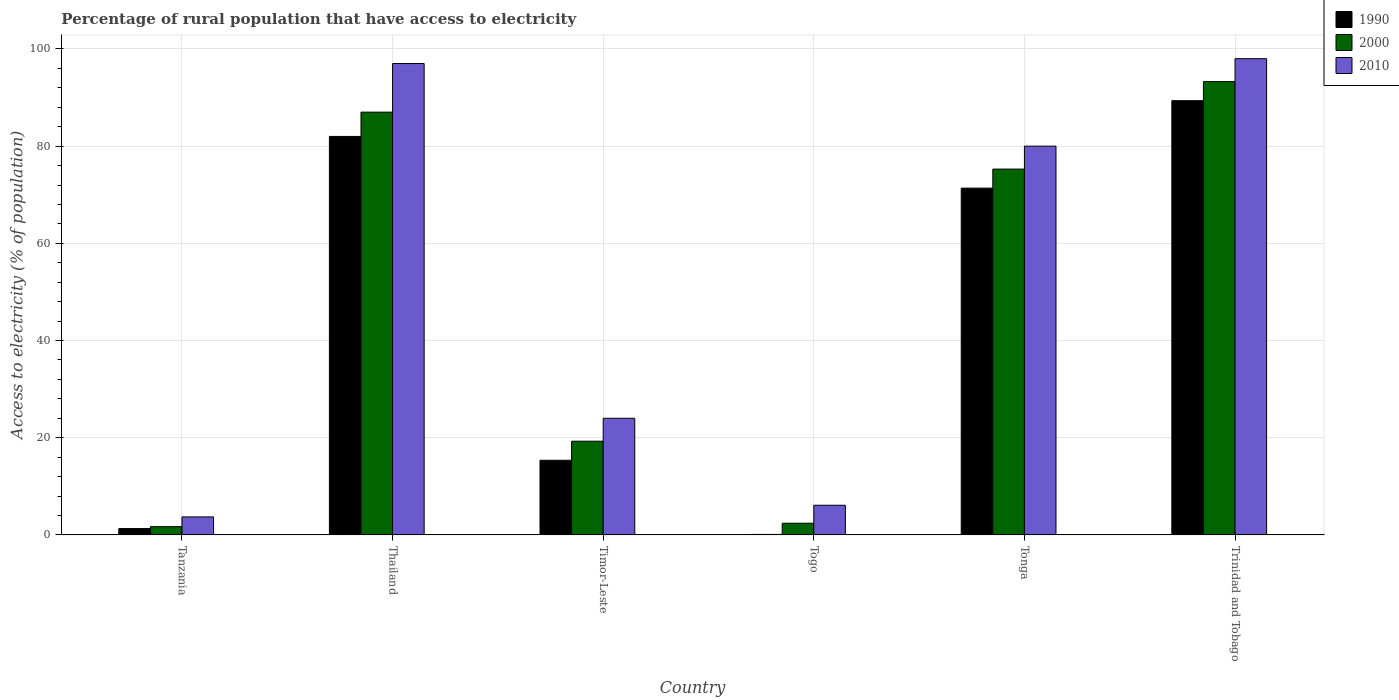Are the number of bars per tick equal to the number of legend labels?
Your answer should be very brief. Yes. Are the number of bars on each tick of the X-axis equal?
Offer a very short reply. Yes. How many bars are there on the 1st tick from the left?
Provide a succinct answer. 3. What is the label of the 1st group of bars from the left?
Your answer should be compact. Tanzania. What is the percentage of rural population that have access to electricity in 1990 in Tonga?
Make the answer very short. 71.36. Across all countries, what is the maximum percentage of rural population that have access to electricity in 2010?
Your response must be concise. 98. In which country was the percentage of rural population that have access to electricity in 2010 maximum?
Your answer should be very brief. Trinidad and Tobago. In which country was the percentage of rural population that have access to electricity in 1990 minimum?
Offer a terse response. Togo. What is the total percentage of rural population that have access to electricity in 1990 in the graph?
Make the answer very short. 259.48. What is the difference between the percentage of rural population that have access to electricity in 1990 in Tanzania and that in Thailand?
Your answer should be compact. -80.7. What is the difference between the percentage of rural population that have access to electricity in 2000 in Timor-Leste and the percentage of rural population that have access to electricity in 1990 in Tanzania?
Offer a very short reply. 17.98. What is the average percentage of rural population that have access to electricity in 2010 per country?
Your answer should be compact. 51.47. What is the difference between the percentage of rural population that have access to electricity of/in 2000 and percentage of rural population that have access to electricity of/in 1990 in Timor-Leste?
Your response must be concise. 3.92. What is the ratio of the percentage of rural population that have access to electricity in 1990 in Tanzania to that in Timor-Leste?
Provide a succinct answer. 0.08. Is the difference between the percentage of rural population that have access to electricity in 2000 in Thailand and Tonga greater than the difference between the percentage of rural population that have access to electricity in 1990 in Thailand and Tonga?
Give a very brief answer. Yes. What is the difference between the highest and the second highest percentage of rural population that have access to electricity in 2000?
Offer a terse response. -18. What is the difference between the highest and the lowest percentage of rural population that have access to electricity in 2000?
Make the answer very short. 91.58. In how many countries, is the percentage of rural population that have access to electricity in 2010 greater than the average percentage of rural population that have access to electricity in 2010 taken over all countries?
Your answer should be very brief. 3. Is the sum of the percentage of rural population that have access to electricity in 2000 in Tanzania and Tonga greater than the maximum percentage of rural population that have access to electricity in 2010 across all countries?
Give a very brief answer. No. What does the 3rd bar from the right in Thailand represents?
Provide a succinct answer. 1990. Is it the case that in every country, the sum of the percentage of rural population that have access to electricity in 2010 and percentage of rural population that have access to electricity in 1990 is greater than the percentage of rural population that have access to electricity in 2000?
Make the answer very short. Yes. How many bars are there?
Provide a succinct answer. 18. Are all the bars in the graph horizontal?
Provide a short and direct response. No. What is the difference between two consecutive major ticks on the Y-axis?
Offer a terse response. 20. How many legend labels are there?
Give a very brief answer. 3. How are the legend labels stacked?
Ensure brevity in your answer.  Vertical. What is the title of the graph?
Your response must be concise. Percentage of rural population that have access to electricity. Does "2008" appear as one of the legend labels in the graph?
Give a very brief answer. No. What is the label or title of the X-axis?
Ensure brevity in your answer.  Country. What is the label or title of the Y-axis?
Keep it short and to the point. Access to electricity (% of population). What is the Access to electricity (% of population) in 1990 in Tanzania?
Offer a terse response. 1.3. What is the Access to electricity (% of population) of 2010 in Thailand?
Your response must be concise. 97. What is the Access to electricity (% of population) in 1990 in Timor-Leste?
Ensure brevity in your answer.  15.36. What is the Access to electricity (% of population) of 2000 in Timor-Leste?
Keep it short and to the point. 19.28. What is the Access to electricity (% of population) in 2010 in Timor-Leste?
Ensure brevity in your answer.  24. What is the Access to electricity (% of population) in 1990 in Togo?
Your answer should be compact. 0.1. What is the Access to electricity (% of population) of 1990 in Tonga?
Offer a terse response. 71.36. What is the Access to electricity (% of population) of 2000 in Tonga?
Provide a succinct answer. 75.28. What is the Access to electricity (% of population) in 2010 in Tonga?
Ensure brevity in your answer.  80. What is the Access to electricity (% of population) in 1990 in Trinidad and Tobago?
Give a very brief answer. 89.36. What is the Access to electricity (% of population) in 2000 in Trinidad and Tobago?
Give a very brief answer. 93.28. Across all countries, what is the maximum Access to electricity (% of population) of 1990?
Provide a succinct answer. 89.36. Across all countries, what is the maximum Access to electricity (% of population) in 2000?
Make the answer very short. 93.28. Across all countries, what is the maximum Access to electricity (% of population) of 2010?
Offer a terse response. 98. Across all countries, what is the minimum Access to electricity (% of population) of 1990?
Ensure brevity in your answer.  0.1. What is the total Access to electricity (% of population) of 1990 in the graph?
Offer a terse response. 259.48. What is the total Access to electricity (% of population) in 2000 in the graph?
Ensure brevity in your answer.  278.94. What is the total Access to electricity (% of population) in 2010 in the graph?
Give a very brief answer. 308.8. What is the difference between the Access to electricity (% of population) in 1990 in Tanzania and that in Thailand?
Your answer should be very brief. -80.7. What is the difference between the Access to electricity (% of population) of 2000 in Tanzania and that in Thailand?
Keep it short and to the point. -85.3. What is the difference between the Access to electricity (% of population) of 2010 in Tanzania and that in Thailand?
Keep it short and to the point. -93.3. What is the difference between the Access to electricity (% of population) in 1990 in Tanzania and that in Timor-Leste?
Provide a short and direct response. -14.06. What is the difference between the Access to electricity (% of population) of 2000 in Tanzania and that in Timor-Leste?
Offer a very short reply. -17.58. What is the difference between the Access to electricity (% of population) in 2010 in Tanzania and that in Timor-Leste?
Make the answer very short. -20.3. What is the difference between the Access to electricity (% of population) of 2000 in Tanzania and that in Togo?
Your answer should be very brief. -0.7. What is the difference between the Access to electricity (% of population) of 1990 in Tanzania and that in Tonga?
Your response must be concise. -70.06. What is the difference between the Access to electricity (% of population) of 2000 in Tanzania and that in Tonga?
Your answer should be compact. -73.58. What is the difference between the Access to electricity (% of population) of 2010 in Tanzania and that in Tonga?
Offer a terse response. -76.3. What is the difference between the Access to electricity (% of population) in 1990 in Tanzania and that in Trinidad and Tobago?
Keep it short and to the point. -88.06. What is the difference between the Access to electricity (% of population) in 2000 in Tanzania and that in Trinidad and Tobago?
Keep it short and to the point. -91.58. What is the difference between the Access to electricity (% of population) in 2010 in Tanzania and that in Trinidad and Tobago?
Ensure brevity in your answer.  -94.3. What is the difference between the Access to electricity (% of population) in 1990 in Thailand and that in Timor-Leste?
Keep it short and to the point. 66.64. What is the difference between the Access to electricity (% of population) in 2000 in Thailand and that in Timor-Leste?
Offer a terse response. 67.72. What is the difference between the Access to electricity (% of population) of 1990 in Thailand and that in Togo?
Make the answer very short. 81.9. What is the difference between the Access to electricity (% of population) in 2000 in Thailand and that in Togo?
Provide a short and direct response. 84.6. What is the difference between the Access to electricity (% of population) of 2010 in Thailand and that in Togo?
Give a very brief answer. 90.9. What is the difference between the Access to electricity (% of population) in 1990 in Thailand and that in Tonga?
Make the answer very short. 10.64. What is the difference between the Access to electricity (% of population) of 2000 in Thailand and that in Tonga?
Make the answer very short. 11.72. What is the difference between the Access to electricity (% of population) of 2010 in Thailand and that in Tonga?
Provide a short and direct response. 17. What is the difference between the Access to electricity (% of population) of 1990 in Thailand and that in Trinidad and Tobago?
Ensure brevity in your answer.  -7.36. What is the difference between the Access to electricity (% of population) in 2000 in Thailand and that in Trinidad and Tobago?
Provide a succinct answer. -6.28. What is the difference between the Access to electricity (% of population) in 1990 in Timor-Leste and that in Togo?
Give a very brief answer. 15.26. What is the difference between the Access to electricity (% of population) in 2000 in Timor-Leste and that in Togo?
Offer a very short reply. 16.88. What is the difference between the Access to electricity (% of population) of 1990 in Timor-Leste and that in Tonga?
Give a very brief answer. -56. What is the difference between the Access to electricity (% of population) in 2000 in Timor-Leste and that in Tonga?
Offer a terse response. -56. What is the difference between the Access to electricity (% of population) in 2010 in Timor-Leste and that in Tonga?
Give a very brief answer. -56. What is the difference between the Access to electricity (% of population) of 1990 in Timor-Leste and that in Trinidad and Tobago?
Offer a very short reply. -74. What is the difference between the Access to electricity (% of population) in 2000 in Timor-Leste and that in Trinidad and Tobago?
Provide a short and direct response. -74. What is the difference between the Access to electricity (% of population) of 2010 in Timor-Leste and that in Trinidad and Tobago?
Your response must be concise. -74. What is the difference between the Access to electricity (% of population) of 1990 in Togo and that in Tonga?
Offer a terse response. -71.26. What is the difference between the Access to electricity (% of population) of 2000 in Togo and that in Tonga?
Keep it short and to the point. -72.88. What is the difference between the Access to electricity (% of population) of 2010 in Togo and that in Tonga?
Provide a succinct answer. -73.9. What is the difference between the Access to electricity (% of population) of 1990 in Togo and that in Trinidad and Tobago?
Ensure brevity in your answer.  -89.26. What is the difference between the Access to electricity (% of population) in 2000 in Togo and that in Trinidad and Tobago?
Keep it short and to the point. -90.88. What is the difference between the Access to electricity (% of population) in 2010 in Togo and that in Trinidad and Tobago?
Your answer should be compact. -91.9. What is the difference between the Access to electricity (% of population) of 2000 in Tonga and that in Trinidad and Tobago?
Your answer should be compact. -18. What is the difference between the Access to electricity (% of population) in 1990 in Tanzania and the Access to electricity (% of population) in 2000 in Thailand?
Make the answer very short. -85.7. What is the difference between the Access to electricity (% of population) in 1990 in Tanzania and the Access to electricity (% of population) in 2010 in Thailand?
Ensure brevity in your answer.  -95.7. What is the difference between the Access to electricity (% of population) of 2000 in Tanzania and the Access to electricity (% of population) of 2010 in Thailand?
Give a very brief answer. -95.3. What is the difference between the Access to electricity (% of population) in 1990 in Tanzania and the Access to electricity (% of population) in 2000 in Timor-Leste?
Your response must be concise. -17.98. What is the difference between the Access to electricity (% of population) of 1990 in Tanzania and the Access to electricity (% of population) of 2010 in Timor-Leste?
Keep it short and to the point. -22.7. What is the difference between the Access to electricity (% of population) of 2000 in Tanzania and the Access to electricity (% of population) of 2010 in Timor-Leste?
Your answer should be very brief. -22.3. What is the difference between the Access to electricity (% of population) of 1990 in Tanzania and the Access to electricity (% of population) of 2010 in Togo?
Make the answer very short. -4.8. What is the difference between the Access to electricity (% of population) in 2000 in Tanzania and the Access to electricity (% of population) in 2010 in Togo?
Offer a terse response. -4.4. What is the difference between the Access to electricity (% of population) in 1990 in Tanzania and the Access to electricity (% of population) in 2000 in Tonga?
Offer a very short reply. -73.98. What is the difference between the Access to electricity (% of population) of 1990 in Tanzania and the Access to electricity (% of population) of 2010 in Tonga?
Give a very brief answer. -78.7. What is the difference between the Access to electricity (% of population) in 2000 in Tanzania and the Access to electricity (% of population) in 2010 in Tonga?
Offer a terse response. -78.3. What is the difference between the Access to electricity (% of population) in 1990 in Tanzania and the Access to electricity (% of population) in 2000 in Trinidad and Tobago?
Make the answer very short. -91.98. What is the difference between the Access to electricity (% of population) of 1990 in Tanzania and the Access to electricity (% of population) of 2010 in Trinidad and Tobago?
Ensure brevity in your answer.  -96.7. What is the difference between the Access to electricity (% of population) in 2000 in Tanzania and the Access to electricity (% of population) in 2010 in Trinidad and Tobago?
Give a very brief answer. -96.3. What is the difference between the Access to electricity (% of population) of 1990 in Thailand and the Access to electricity (% of population) of 2000 in Timor-Leste?
Provide a short and direct response. 62.72. What is the difference between the Access to electricity (% of population) of 1990 in Thailand and the Access to electricity (% of population) of 2010 in Timor-Leste?
Your response must be concise. 58. What is the difference between the Access to electricity (% of population) of 1990 in Thailand and the Access to electricity (% of population) of 2000 in Togo?
Make the answer very short. 79.6. What is the difference between the Access to electricity (% of population) in 1990 in Thailand and the Access to electricity (% of population) in 2010 in Togo?
Your response must be concise. 75.9. What is the difference between the Access to electricity (% of population) in 2000 in Thailand and the Access to electricity (% of population) in 2010 in Togo?
Give a very brief answer. 80.9. What is the difference between the Access to electricity (% of population) of 1990 in Thailand and the Access to electricity (% of population) of 2000 in Tonga?
Offer a very short reply. 6.72. What is the difference between the Access to electricity (% of population) in 1990 in Thailand and the Access to electricity (% of population) in 2010 in Tonga?
Ensure brevity in your answer.  2. What is the difference between the Access to electricity (% of population) of 1990 in Thailand and the Access to electricity (% of population) of 2000 in Trinidad and Tobago?
Offer a terse response. -11.28. What is the difference between the Access to electricity (% of population) in 1990 in Thailand and the Access to electricity (% of population) in 2010 in Trinidad and Tobago?
Give a very brief answer. -16. What is the difference between the Access to electricity (% of population) of 1990 in Timor-Leste and the Access to electricity (% of population) of 2000 in Togo?
Your answer should be compact. 12.96. What is the difference between the Access to electricity (% of population) of 1990 in Timor-Leste and the Access to electricity (% of population) of 2010 in Togo?
Offer a terse response. 9.26. What is the difference between the Access to electricity (% of population) of 2000 in Timor-Leste and the Access to electricity (% of population) of 2010 in Togo?
Offer a terse response. 13.18. What is the difference between the Access to electricity (% of population) of 1990 in Timor-Leste and the Access to electricity (% of population) of 2000 in Tonga?
Ensure brevity in your answer.  -59.92. What is the difference between the Access to electricity (% of population) in 1990 in Timor-Leste and the Access to electricity (% of population) in 2010 in Tonga?
Offer a terse response. -64.64. What is the difference between the Access to electricity (% of population) of 2000 in Timor-Leste and the Access to electricity (% of population) of 2010 in Tonga?
Make the answer very short. -60.72. What is the difference between the Access to electricity (% of population) of 1990 in Timor-Leste and the Access to electricity (% of population) of 2000 in Trinidad and Tobago?
Provide a short and direct response. -77.92. What is the difference between the Access to electricity (% of population) of 1990 in Timor-Leste and the Access to electricity (% of population) of 2010 in Trinidad and Tobago?
Keep it short and to the point. -82.64. What is the difference between the Access to electricity (% of population) in 2000 in Timor-Leste and the Access to electricity (% of population) in 2010 in Trinidad and Tobago?
Your answer should be very brief. -78.72. What is the difference between the Access to electricity (% of population) in 1990 in Togo and the Access to electricity (% of population) in 2000 in Tonga?
Make the answer very short. -75.18. What is the difference between the Access to electricity (% of population) of 1990 in Togo and the Access to electricity (% of population) of 2010 in Tonga?
Your answer should be very brief. -79.9. What is the difference between the Access to electricity (% of population) of 2000 in Togo and the Access to electricity (% of population) of 2010 in Tonga?
Keep it short and to the point. -77.6. What is the difference between the Access to electricity (% of population) in 1990 in Togo and the Access to electricity (% of population) in 2000 in Trinidad and Tobago?
Your response must be concise. -93.18. What is the difference between the Access to electricity (% of population) in 1990 in Togo and the Access to electricity (% of population) in 2010 in Trinidad and Tobago?
Offer a very short reply. -97.9. What is the difference between the Access to electricity (% of population) of 2000 in Togo and the Access to electricity (% of population) of 2010 in Trinidad and Tobago?
Your answer should be very brief. -95.6. What is the difference between the Access to electricity (% of population) of 1990 in Tonga and the Access to electricity (% of population) of 2000 in Trinidad and Tobago?
Offer a very short reply. -21.92. What is the difference between the Access to electricity (% of population) of 1990 in Tonga and the Access to electricity (% of population) of 2010 in Trinidad and Tobago?
Your response must be concise. -26.64. What is the difference between the Access to electricity (% of population) in 2000 in Tonga and the Access to electricity (% of population) in 2010 in Trinidad and Tobago?
Provide a short and direct response. -22.72. What is the average Access to electricity (% of population) of 1990 per country?
Your response must be concise. 43.25. What is the average Access to electricity (% of population) in 2000 per country?
Provide a short and direct response. 46.49. What is the average Access to electricity (% of population) of 2010 per country?
Your answer should be compact. 51.47. What is the difference between the Access to electricity (% of population) of 2000 and Access to electricity (% of population) of 2010 in Tanzania?
Provide a succinct answer. -2. What is the difference between the Access to electricity (% of population) in 1990 and Access to electricity (% of population) in 2000 in Thailand?
Provide a short and direct response. -5. What is the difference between the Access to electricity (% of population) in 1990 and Access to electricity (% of population) in 2010 in Thailand?
Keep it short and to the point. -15. What is the difference between the Access to electricity (% of population) in 1990 and Access to electricity (% of population) in 2000 in Timor-Leste?
Offer a very short reply. -3.92. What is the difference between the Access to electricity (% of population) in 1990 and Access to electricity (% of population) in 2010 in Timor-Leste?
Offer a terse response. -8.64. What is the difference between the Access to electricity (% of population) in 2000 and Access to electricity (% of population) in 2010 in Timor-Leste?
Keep it short and to the point. -4.72. What is the difference between the Access to electricity (% of population) in 1990 and Access to electricity (% of population) in 2000 in Togo?
Your response must be concise. -2.3. What is the difference between the Access to electricity (% of population) in 1990 and Access to electricity (% of population) in 2010 in Togo?
Your response must be concise. -6. What is the difference between the Access to electricity (% of population) of 2000 and Access to electricity (% of population) of 2010 in Togo?
Your response must be concise. -3.7. What is the difference between the Access to electricity (% of population) of 1990 and Access to electricity (% of population) of 2000 in Tonga?
Your response must be concise. -3.92. What is the difference between the Access to electricity (% of population) in 1990 and Access to electricity (% of population) in 2010 in Tonga?
Give a very brief answer. -8.64. What is the difference between the Access to electricity (% of population) in 2000 and Access to electricity (% of population) in 2010 in Tonga?
Your response must be concise. -4.72. What is the difference between the Access to electricity (% of population) in 1990 and Access to electricity (% of population) in 2000 in Trinidad and Tobago?
Provide a succinct answer. -3.92. What is the difference between the Access to electricity (% of population) in 1990 and Access to electricity (% of population) in 2010 in Trinidad and Tobago?
Provide a short and direct response. -8.64. What is the difference between the Access to electricity (% of population) of 2000 and Access to electricity (% of population) of 2010 in Trinidad and Tobago?
Your answer should be compact. -4.72. What is the ratio of the Access to electricity (% of population) in 1990 in Tanzania to that in Thailand?
Make the answer very short. 0.02. What is the ratio of the Access to electricity (% of population) in 2000 in Tanzania to that in Thailand?
Your answer should be very brief. 0.02. What is the ratio of the Access to electricity (% of population) in 2010 in Tanzania to that in Thailand?
Your response must be concise. 0.04. What is the ratio of the Access to electricity (% of population) of 1990 in Tanzania to that in Timor-Leste?
Provide a short and direct response. 0.08. What is the ratio of the Access to electricity (% of population) of 2000 in Tanzania to that in Timor-Leste?
Provide a short and direct response. 0.09. What is the ratio of the Access to electricity (% of population) of 2010 in Tanzania to that in Timor-Leste?
Offer a terse response. 0.15. What is the ratio of the Access to electricity (% of population) in 2000 in Tanzania to that in Togo?
Ensure brevity in your answer.  0.71. What is the ratio of the Access to electricity (% of population) of 2010 in Tanzania to that in Togo?
Offer a terse response. 0.61. What is the ratio of the Access to electricity (% of population) in 1990 in Tanzania to that in Tonga?
Make the answer very short. 0.02. What is the ratio of the Access to electricity (% of population) in 2000 in Tanzania to that in Tonga?
Ensure brevity in your answer.  0.02. What is the ratio of the Access to electricity (% of population) in 2010 in Tanzania to that in Tonga?
Provide a succinct answer. 0.05. What is the ratio of the Access to electricity (% of population) of 1990 in Tanzania to that in Trinidad and Tobago?
Provide a short and direct response. 0.01. What is the ratio of the Access to electricity (% of population) of 2000 in Tanzania to that in Trinidad and Tobago?
Ensure brevity in your answer.  0.02. What is the ratio of the Access to electricity (% of population) of 2010 in Tanzania to that in Trinidad and Tobago?
Provide a short and direct response. 0.04. What is the ratio of the Access to electricity (% of population) of 1990 in Thailand to that in Timor-Leste?
Offer a terse response. 5.34. What is the ratio of the Access to electricity (% of population) in 2000 in Thailand to that in Timor-Leste?
Offer a very short reply. 4.51. What is the ratio of the Access to electricity (% of population) in 2010 in Thailand to that in Timor-Leste?
Your answer should be very brief. 4.04. What is the ratio of the Access to electricity (% of population) in 1990 in Thailand to that in Togo?
Offer a very short reply. 820. What is the ratio of the Access to electricity (% of population) of 2000 in Thailand to that in Togo?
Offer a very short reply. 36.25. What is the ratio of the Access to electricity (% of population) of 2010 in Thailand to that in Togo?
Ensure brevity in your answer.  15.9. What is the ratio of the Access to electricity (% of population) of 1990 in Thailand to that in Tonga?
Offer a very short reply. 1.15. What is the ratio of the Access to electricity (% of population) in 2000 in Thailand to that in Tonga?
Your answer should be compact. 1.16. What is the ratio of the Access to electricity (% of population) in 2010 in Thailand to that in Tonga?
Provide a short and direct response. 1.21. What is the ratio of the Access to electricity (% of population) in 1990 in Thailand to that in Trinidad and Tobago?
Offer a terse response. 0.92. What is the ratio of the Access to electricity (% of population) in 2000 in Thailand to that in Trinidad and Tobago?
Make the answer very short. 0.93. What is the ratio of the Access to electricity (% of population) of 2010 in Thailand to that in Trinidad and Tobago?
Your response must be concise. 0.99. What is the ratio of the Access to electricity (% of population) in 1990 in Timor-Leste to that in Togo?
Offer a very short reply. 153.6. What is the ratio of the Access to electricity (% of population) of 2000 in Timor-Leste to that in Togo?
Provide a succinct answer. 8.03. What is the ratio of the Access to electricity (% of population) in 2010 in Timor-Leste to that in Togo?
Keep it short and to the point. 3.93. What is the ratio of the Access to electricity (% of population) in 1990 in Timor-Leste to that in Tonga?
Offer a very short reply. 0.22. What is the ratio of the Access to electricity (% of population) of 2000 in Timor-Leste to that in Tonga?
Give a very brief answer. 0.26. What is the ratio of the Access to electricity (% of population) in 2010 in Timor-Leste to that in Tonga?
Your answer should be very brief. 0.3. What is the ratio of the Access to electricity (% of population) of 1990 in Timor-Leste to that in Trinidad and Tobago?
Provide a short and direct response. 0.17. What is the ratio of the Access to electricity (% of population) of 2000 in Timor-Leste to that in Trinidad and Tobago?
Provide a short and direct response. 0.21. What is the ratio of the Access to electricity (% of population) of 2010 in Timor-Leste to that in Trinidad and Tobago?
Your response must be concise. 0.24. What is the ratio of the Access to electricity (% of population) in 1990 in Togo to that in Tonga?
Keep it short and to the point. 0. What is the ratio of the Access to electricity (% of population) in 2000 in Togo to that in Tonga?
Your response must be concise. 0.03. What is the ratio of the Access to electricity (% of population) of 2010 in Togo to that in Tonga?
Provide a succinct answer. 0.08. What is the ratio of the Access to electricity (% of population) of 1990 in Togo to that in Trinidad and Tobago?
Provide a succinct answer. 0. What is the ratio of the Access to electricity (% of population) of 2000 in Togo to that in Trinidad and Tobago?
Offer a very short reply. 0.03. What is the ratio of the Access to electricity (% of population) of 2010 in Togo to that in Trinidad and Tobago?
Keep it short and to the point. 0.06. What is the ratio of the Access to electricity (% of population) in 1990 in Tonga to that in Trinidad and Tobago?
Your answer should be very brief. 0.8. What is the ratio of the Access to electricity (% of population) in 2000 in Tonga to that in Trinidad and Tobago?
Provide a short and direct response. 0.81. What is the ratio of the Access to electricity (% of population) in 2010 in Tonga to that in Trinidad and Tobago?
Give a very brief answer. 0.82. What is the difference between the highest and the second highest Access to electricity (% of population) of 1990?
Ensure brevity in your answer.  7.36. What is the difference between the highest and the second highest Access to electricity (% of population) of 2000?
Your response must be concise. 6.28. What is the difference between the highest and the lowest Access to electricity (% of population) in 1990?
Keep it short and to the point. 89.26. What is the difference between the highest and the lowest Access to electricity (% of population) in 2000?
Your answer should be very brief. 91.58. What is the difference between the highest and the lowest Access to electricity (% of population) in 2010?
Make the answer very short. 94.3. 